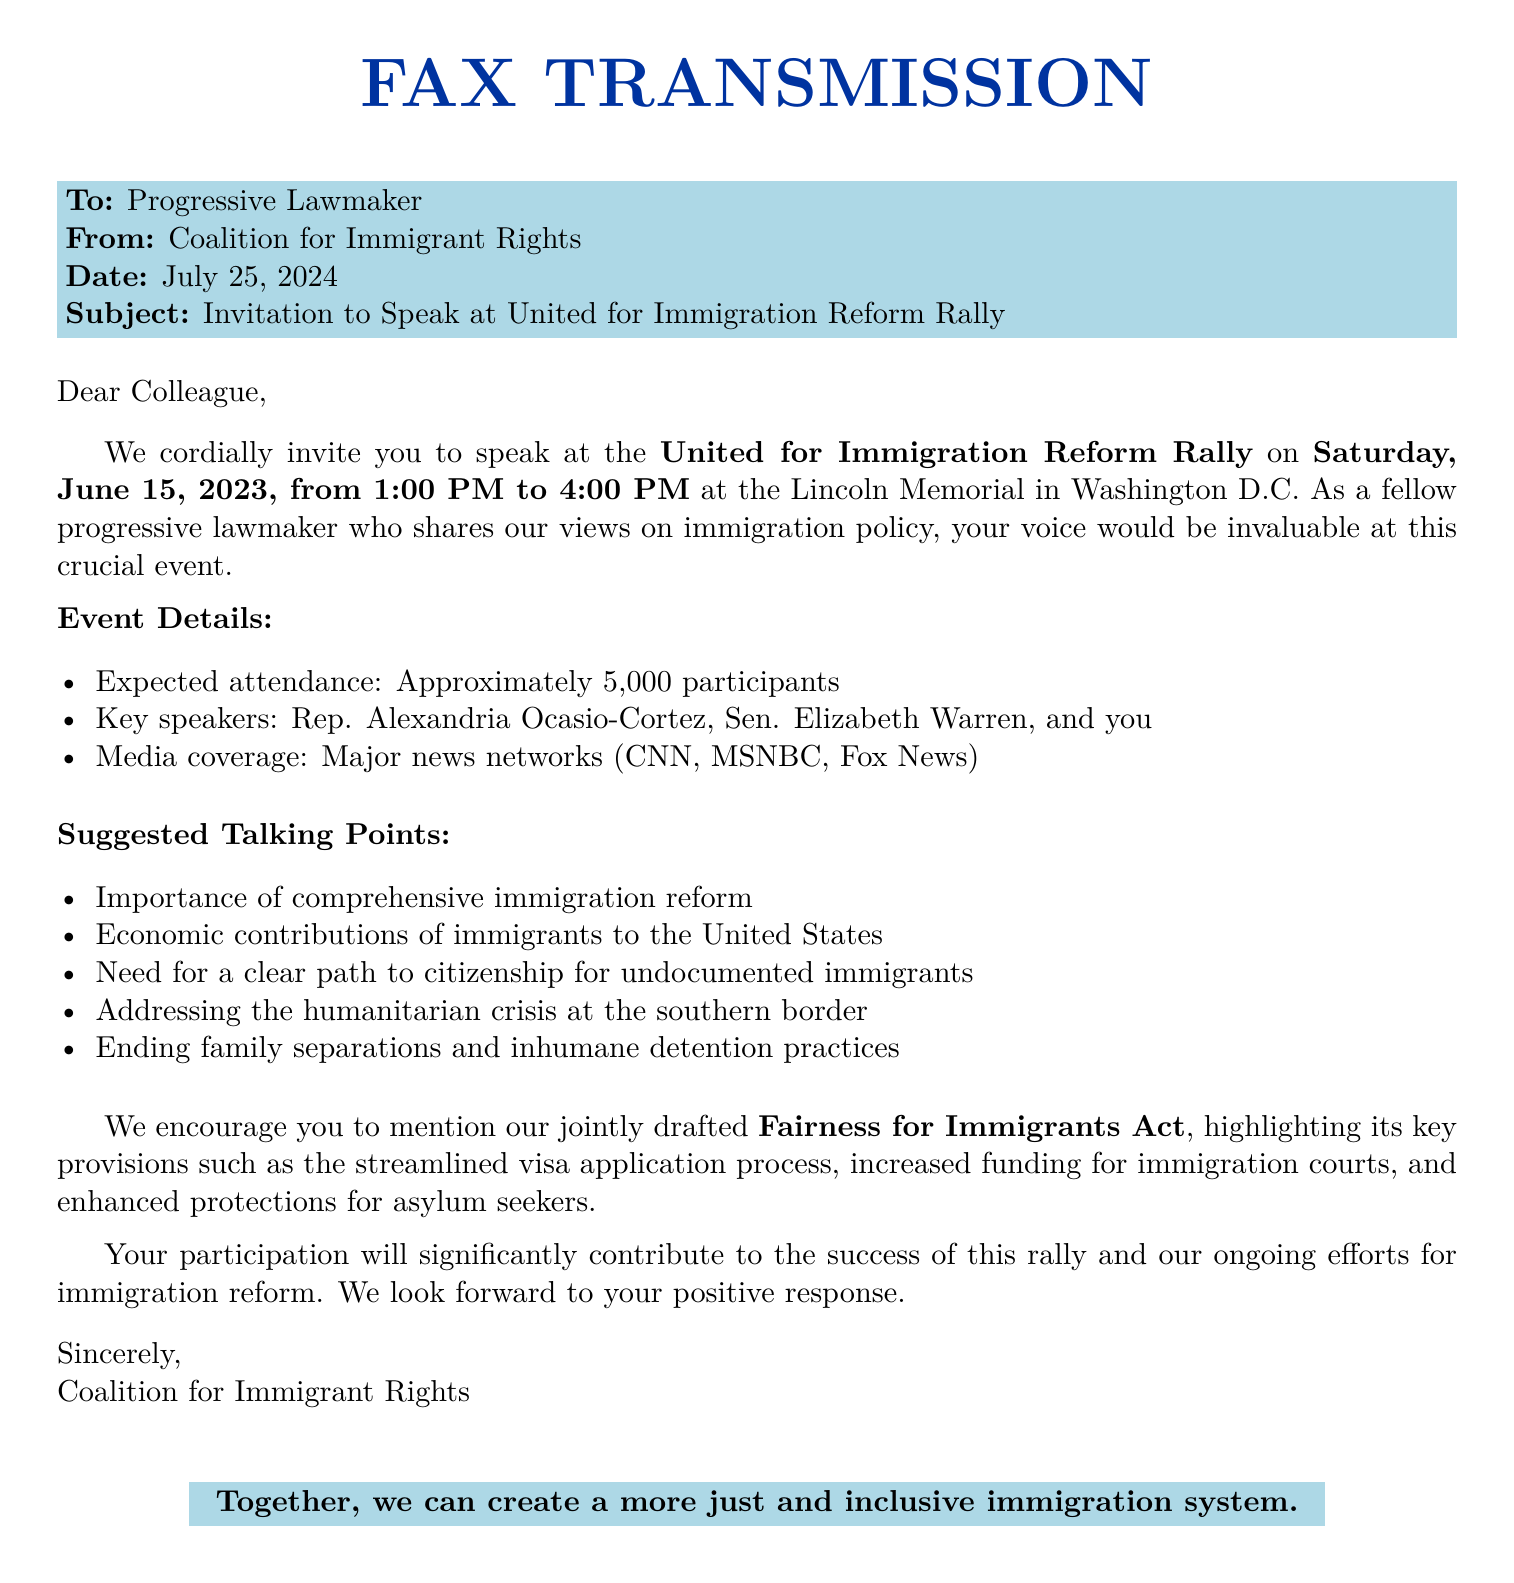What is the date of the rally? The date of the rally is mentioned in the document as June 15, 2023.
Answer: June 15, 2023 Where is the rally taking place? The location of the rally is specified in the document as the Lincoln Memorial in Washington D.C.
Answer: Lincoln Memorial, Washington D.C Who are the key speakers at the event? Key speakers are listed in the document: Rep. Alexandria Ocasio-Cortez, Sen. Elizabeth Warren, and you.
Answer: Rep. Alexandria Ocasio-Cortez, Sen. Elizabeth Warren, and you What is the expected attendance of the rally? The document states that approximately 5,000 participants are expected to attend the event.
Answer: Approximately 5,000 participants What are the suggested talking points? The document highlights several suggested talking points that cover critical aspects of immigration reform.
Answer: Importance of comprehensive immigration reform, Economic contributions of immigrants to the United States, Need for a clear path to citizenship for undocumented immigrants, Addressing the humanitarian crisis at the southern border, Ending family separations and inhumane detention practices What media coverage is expected at the rally? The document mentions that major news networks, including CNN, MSNBC, and Fox News, will cover the event.
Answer: CNN, MSNBC, Fox News What act does the document encourage mentioning during the speech? The document specifies to mention the "Fairness for Immigrants Act" during the speech.
Answer: Fairness for Immigrants Act What is the primary purpose of the rally? The document's purpose indicates the rally aims to promote immigration reform.
Answer: To promote immigration reform What organization is sending the fax? The sender of the fax is identified as the Coalition for Immigrant Rights in the document.
Answer: Coalition for Immigrant Rights 